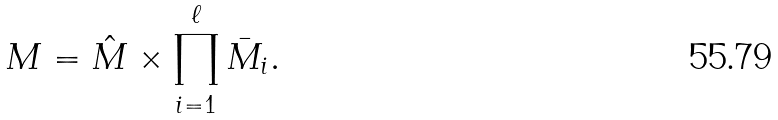<formula> <loc_0><loc_0><loc_500><loc_500>M = \hat { M } \times \prod _ { i = 1 } ^ { \ell } \bar { M } _ { i } .</formula> 